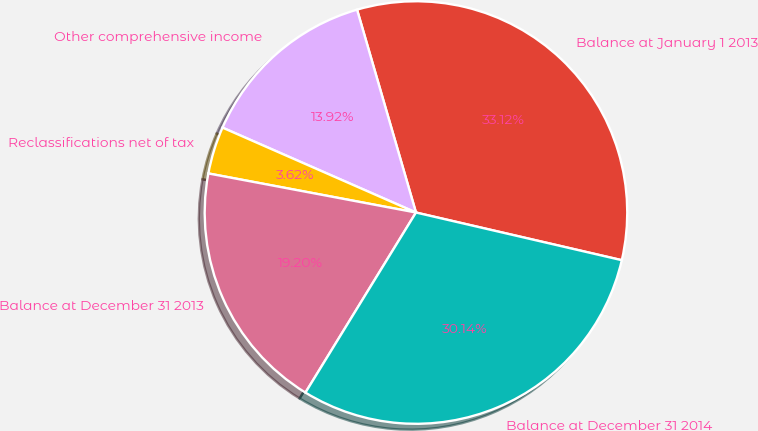Convert chart. <chart><loc_0><loc_0><loc_500><loc_500><pie_chart><fcel>Balance at January 1 2013<fcel>Other comprehensive income<fcel>Reclassifications net of tax<fcel>Balance at December 31 2013<fcel>Balance at December 31 2014<nl><fcel>33.12%<fcel>13.92%<fcel>3.62%<fcel>19.2%<fcel>30.14%<nl></chart> 